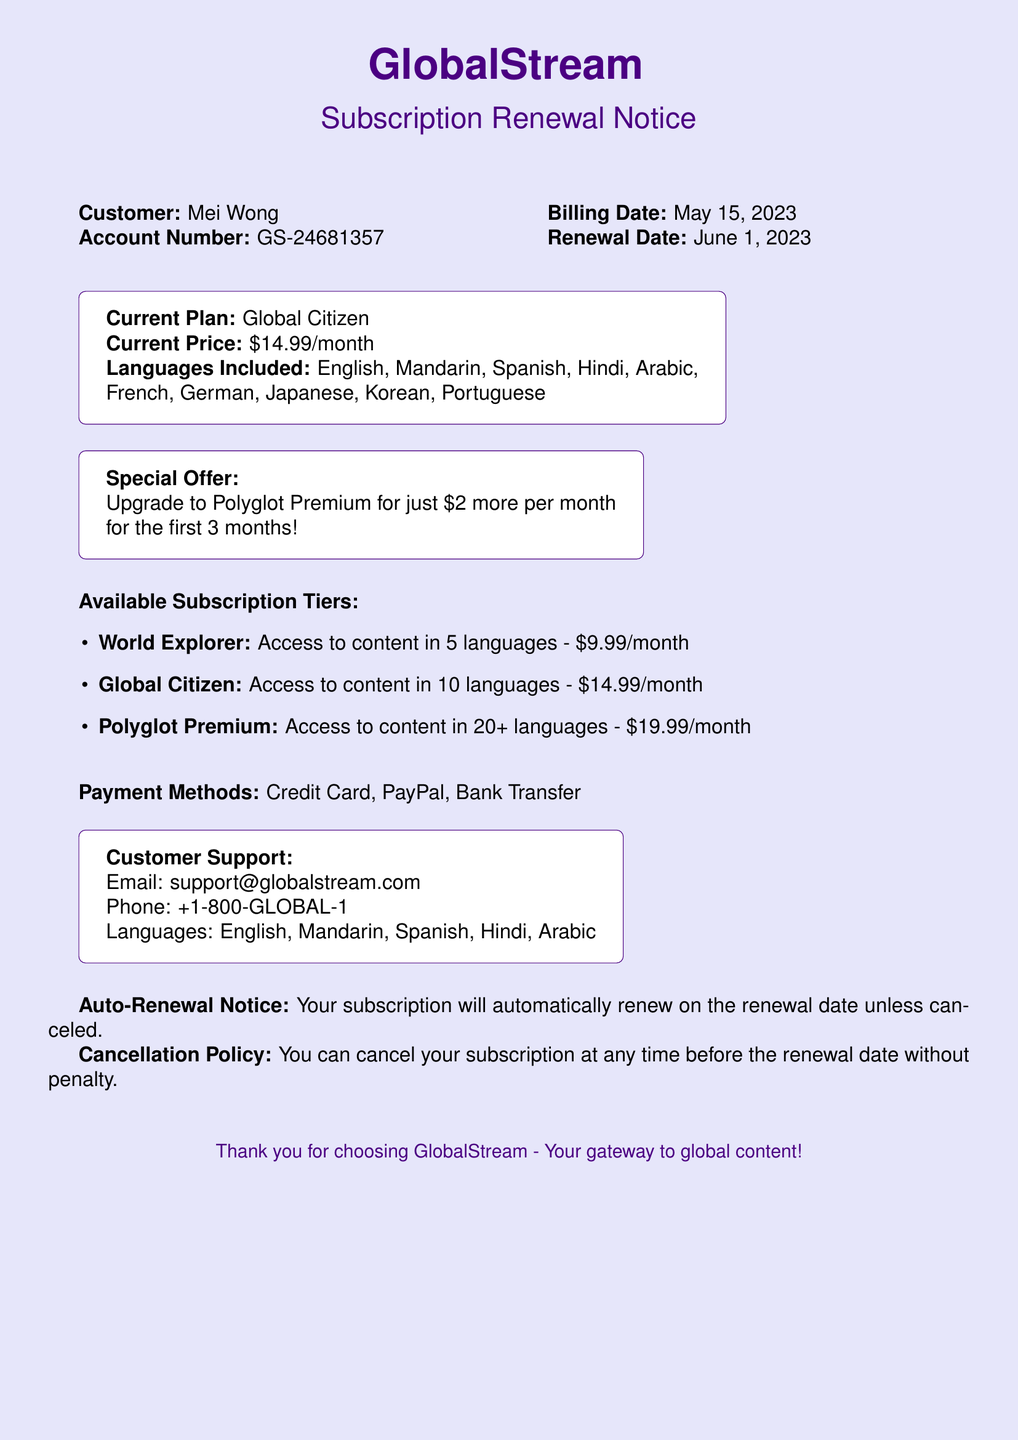What is the customer's name? The customer's name is provided in the document under the customer section.
Answer: Mei Wong What is the account number? The account number is displayed alongside the customer's name in the billing section.
Answer: GS-24681357 What is the current price of the subscription? The current price is shown in the subscription details section.
Answer: $14.99/month When is the renewal date? The renewal date is specified in the billing information section.
Answer: June 1, 2023 What special offer is available? The document mentions a specific promotion for upgrading plans.
Answer: Upgrade to Polyglot Premium for just $2 more per month What are the available subscription tiers? The document outlines the different subscription tiers and their prices.
Answer: World Explorer, Global Citizen, Polyglot Premium What languages are included in the current plan? The languages included are listed in the subscription details section.
Answer: English, Mandarin, Spanish, Hindi, Arabic, French, German, Japanese, Korean, Portuguese What is the cancellation policy? The cancellation policy is described towards the end of the document.
Answer: You can cancel your subscription at any time before the renewal date without penalty What payment methods are accepted? The accepted payment methods are listed in a specific section of the document.
Answer: Credit Card, PayPal, Bank Transfer What is the customer support email? The customer support email is provided in the customer support section.
Answer: support@globalstream.com 